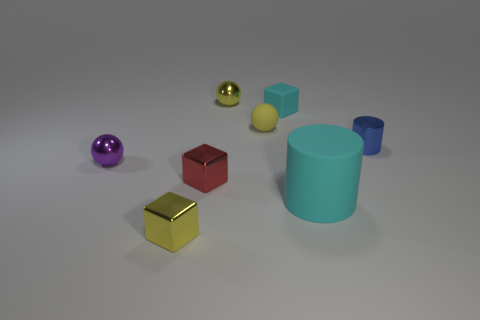Subtract all yellow metallic blocks. How many blocks are left? 2 Subtract all cylinders. How many objects are left? 6 Subtract 1 red blocks. How many objects are left? 7 Subtract 2 spheres. How many spheres are left? 1 Subtract all blue cylinders. Subtract all yellow cubes. How many cylinders are left? 1 Subtract all yellow cylinders. How many green balls are left? 0 Subtract all cyan rubber cylinders. Subtract all metal cylinders. How many objects are left? 6 Add 7 metal cylinders. How many metal cylinders are left? 8 Add 4 cyan matte blocks. How many cyan matte blocks exist? 5 Add 2 big yellow metal cubes. How many objects exist? 10 